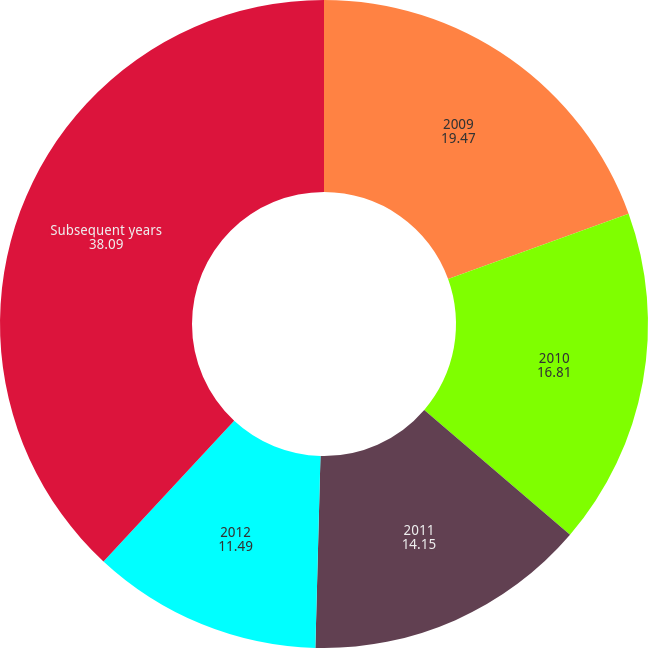Convert chart to OTSL. <chart><loc_0><loc_0><loc_500><loc_500><pie_chart><fcel>2009<fcel>2010<fcel>2011<fcel>2012<fcel>Subsequent years<nl><fcel>19.47%<fcel>16.81%<fcel>14.15%<fcel>11.49%<fcel>38.09%<nl></chart> 